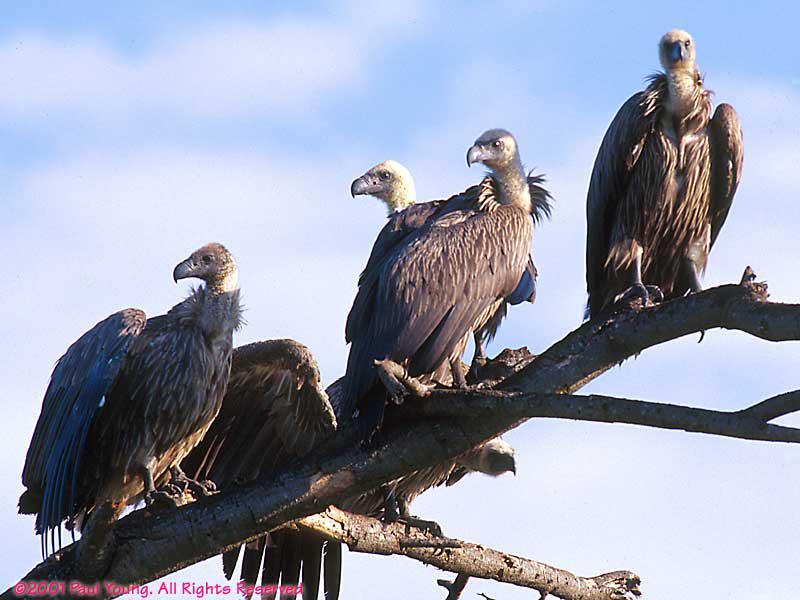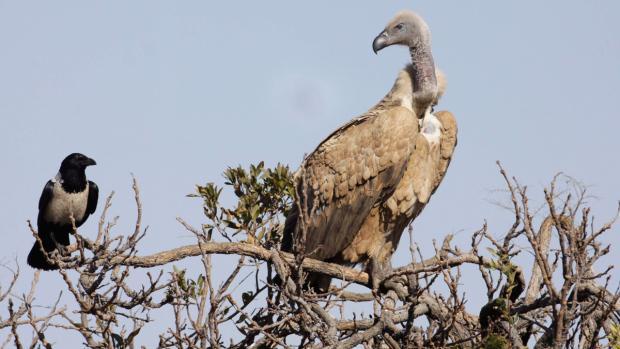The first image is the image on the left, the second image is the image on the right. Assess this claim about the two images: "There is at least one bird sitting on a branch in each picture.". Correct or not? Answer yes or no. Yes. 